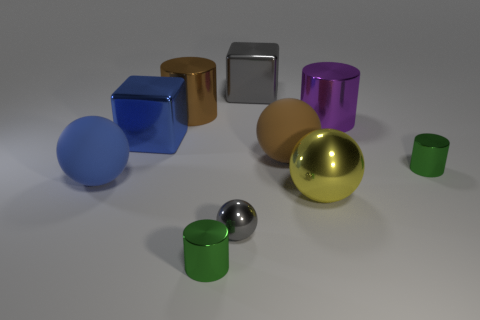Do the objects in the image serve a specific function or are they purely decorative? The objects in the image appear to be more aesthetic in nature, possibly serving as models to demonstrate various geometric shapes and materials. There is no clear indication that they have a specific function beyond that. What materials are the other objects made of? The objects display various materials with different properties: the spheres and cubes have reflective surfaces suggesting metal or polished stone; the blue and green objects have a matte finish and may be made of plastic or painted wood. 